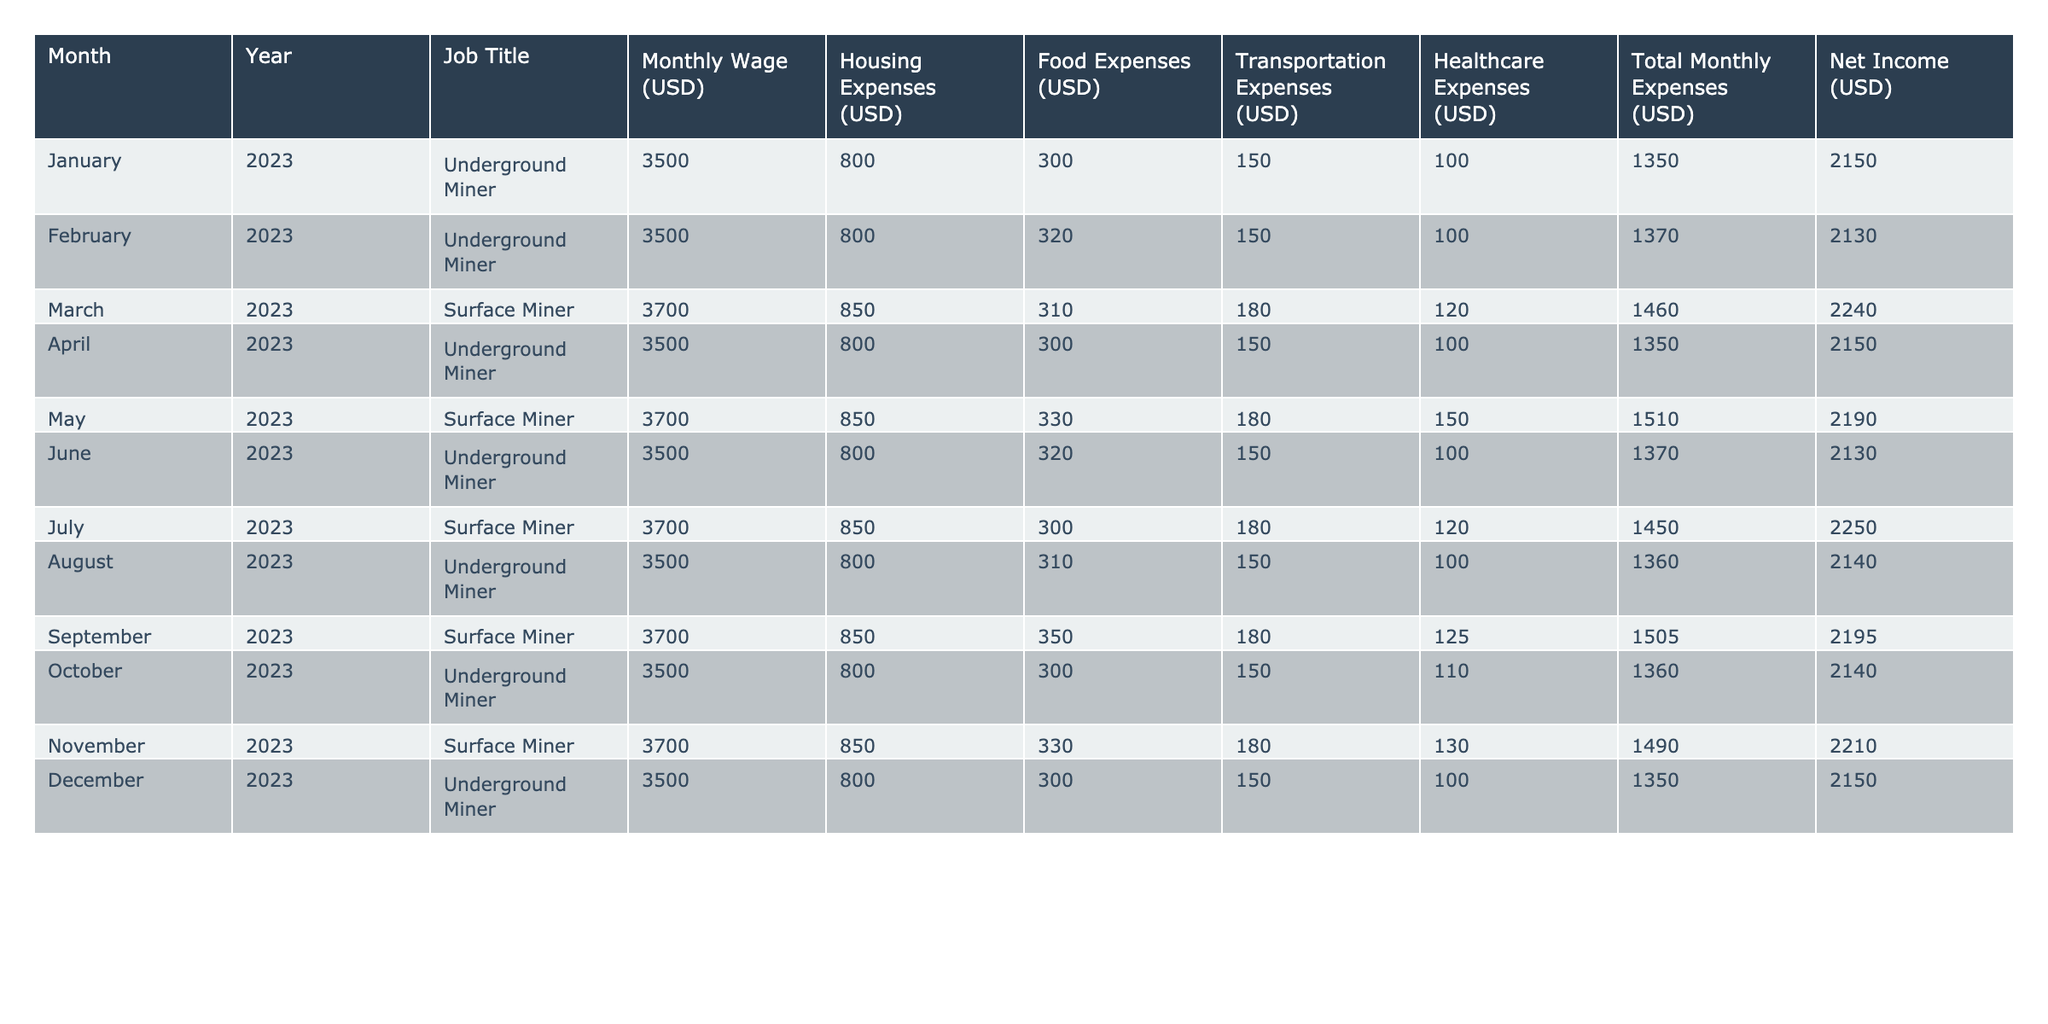What is the total monthly wage for an Underground Miner? The table shows that the Monthly Wage for an Underground Miner is consistently 3500 USD.
Answer: 3500 USD What is the highest monthly wage recorded in the table? The table indicates that the highest monthly wage is for the Surface Miner, at 3700 USD.
Answer: 3700 USD How much did the Surface Miner earn in November 2023? For November 2023, the Surface Miner earned a monthly wage of 3700 USD.
Answer: 3700 USD What are the total monthly expenses for the Surface Miner in July 2023? According to the table, the total monthly expenses for the Surface Miner in July 2023 were 1450 USD.
Answer: 1450 USD What was the net income for the Underground Miner in June 2023? The net income for the Underground Miner in June 2023 was reported as 2130 USD.
Answer: 2130 USD Which month had the highest housing expenses for Underground Miners? The housing expenses for Underground Miners were 800 USD consistently, so no month had higher expenses.
Answer: No month What is the average food expense for Surface Miners over the year? Summing the food expenses for Surface Miners: (310 + 330 + 300 + 350 + 330) = 1650 USD. There are 5 data points, so average is 1650/5 = 330 USD.
Answer: 330 USD What is the difference between the net incomes of Surface and Underground Miners in December 2023? The net income for Underground Miner in December 2023 is 2150 USD, and for Surface Miner is not applicable as there is no entry. Hence, the difference is simply 2150 USD.
Answer: 2150 USD Is there a month where the net income for the Underground Miner was less than 2100 USD? Reviewing the table, all entries for Underground Miners show net incomes of either 2130 or 2150 USD; none are less than 2100 USD.
Answer: No How did the transportation expenses change for the Underground Miner from January to October 2023? The transportation expenses remained consistent at 150 USD from January to October 2023, with only minor variations in total expenses.
Answer: No change What is the total net income earned by Surface Miners over the year? The total net income for Surface Miners is (2240 + 2190 + 2250 + 2195 + 2210) = 11185 USD. This sum gives us their total net income over the entries provided.
Answer: 11185 USD 